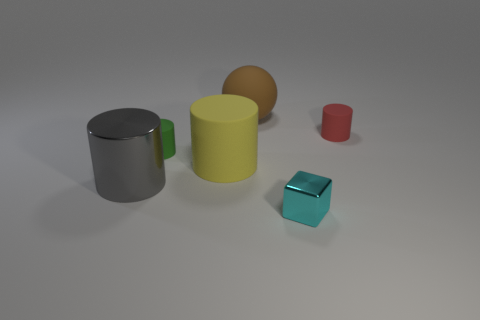Subtract all matte cylinders. How many cylinders are left? 1 Add 2 tiny matte things. How many objects exist? 8 Subtract all yellow cylinders. How many cylinders are left? 3 Subtract 1 blocks. How many blocks are left? 0 Subtract all green balls. Subtract all purple cylinders. How many balls are left? 1 Subtract all purple blocks. How many blue cylinders are left? 0 Add 6 tiny red things. How many tiny red things are left? 7 Add 4 large yellow cylinders. How many large yellow cylinders exist? 5 Subtract 0 blue cubes. How many objects are left? 6 Subtract all blocks. How many objects are left? 5 